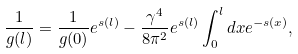<formula> <loc_0><loc_0><loc_500><loc_500>\frac { 1 } { g ( l ) } = \frac { 1 } { g ( 0 ) } e ^ { s ( l ) } - \frac { \gamma ^ { 4 } } { 8 \pi ^ { 2 } } e ^ { s ( l ) } \int _ { 0 } ^ { l } d x e ^ { - s ( x ) } ,</formula> 